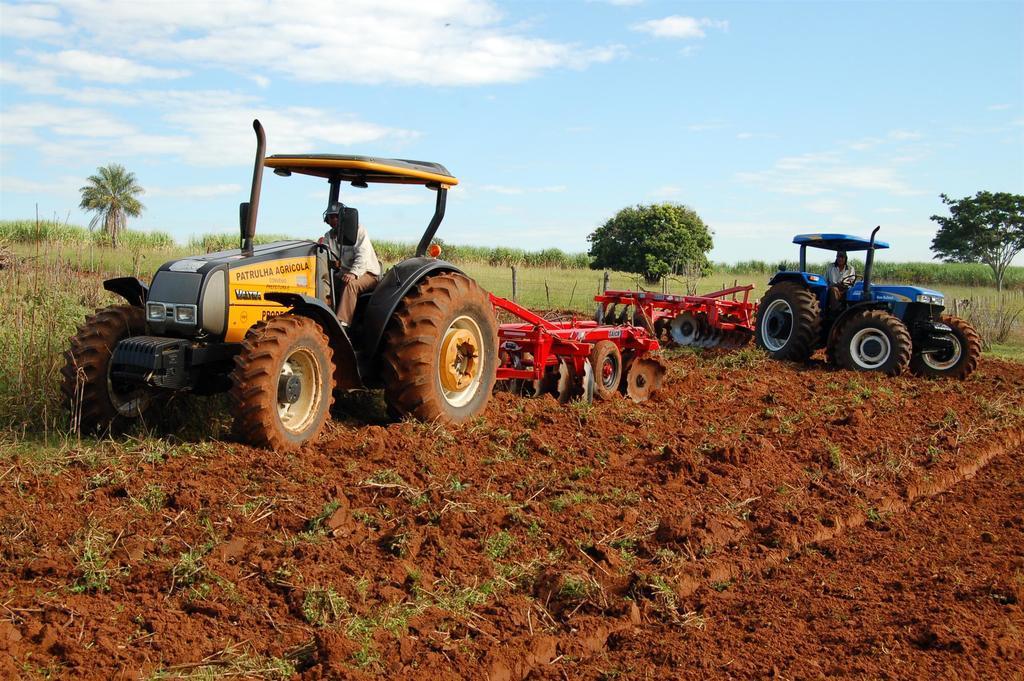How would you summarize this image in a sentence or two? In this image two vehicles are on the land. Left side a person is sitting in the vehicle. He is wearing a cap. Background there are few plants and trees. Top of the image there is sky with some clouds. Right side there is a person sitting in the vehicle. 